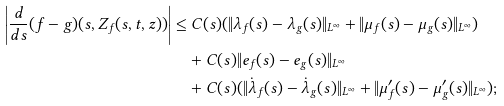Convert formula to latex. <formula><loc_0><loc_0><loc_500><loc_500>\left | \frac { d } { d s } ( f - g ) ( s , Z _ { f } ( s , t , z ) ) \right | & \leq C ( s ) ( \| \lambda _ { f } ( s ) - \lambda _ { g } ( s ) \| _ { L ^ { \infty } } + \| \mu _ { f } ( s ) - \mu _ { g } ( s ) \| _ { L ^ { \infty } } ) \\ & \quad + C ( s ) \| e _ { f } ( s ) - e _ { g } ( s ) \| _ { L ^ { \infty } } \\ & \quad + C ( s ) ( \| \dot { \lambda } _ { f } ( s ) - \dot { \lambda } _ { g } ( s ) \| _ { L ^ { \infty } } + \| \mu ^ { \prime } _ { f } ( s ) - \mu ^ { \prime } _ { g } ( s ) \| _ { L ^ { \infty } } ) ;</formula> 